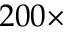Convert formula to latex. <formula><loc_0><loc_0><loc_500><loc_500>2 0 0 \times</formula> 